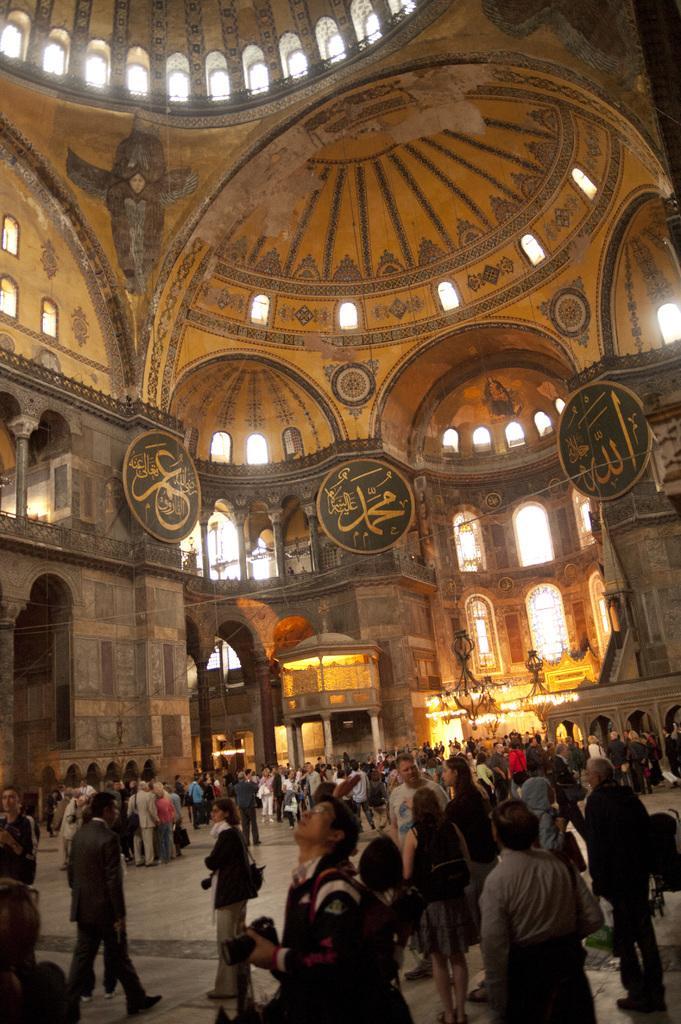Describe this image in one or two sentences. In this image, we can see an inside view of a fort. There is a crowd at the bottom of the image. There are some windows in the middle of the image. 